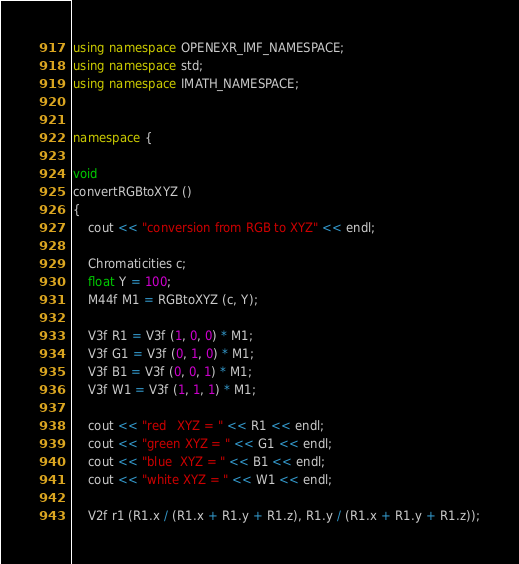<code> <loc_0><loc_0><loc_500><loc_500><_C++_>using namespace OPENEXR_IMF_NAMESPACE;
using namespace std;
using namespace IMATH_NAMESPACE;


namespace {

void
convertRGBtoXYZ ()
{
    cout << "conversion from RGB to XYZ" << endl;

    Chromaticities c;
    float Y = 100;
    M44f M1 = RGBtoXYZ (c, Y);

    V3f R1 = V3f (1, 0, 0) * M1;
    V3f G1 = V3f (0, 1, 0) * M1;
    V3f B1 = V3f (0, 0, 1) * M1;
    V3f W1 = V3f (1, 1, 1) * M1;

    cout << "red   XYZ = " << R1 << endl;
    cout << "green XYZ = " << G1 << endl;
    cout << "blue  XYZ = " << B1 << endl;
    cout << "white XYZ = " << W1 << endl;

    V2f r1 (R1.x / (R1.x + R1.y + R1.z), R1.y / (R1.x + R1.y + R1.z));</code> 